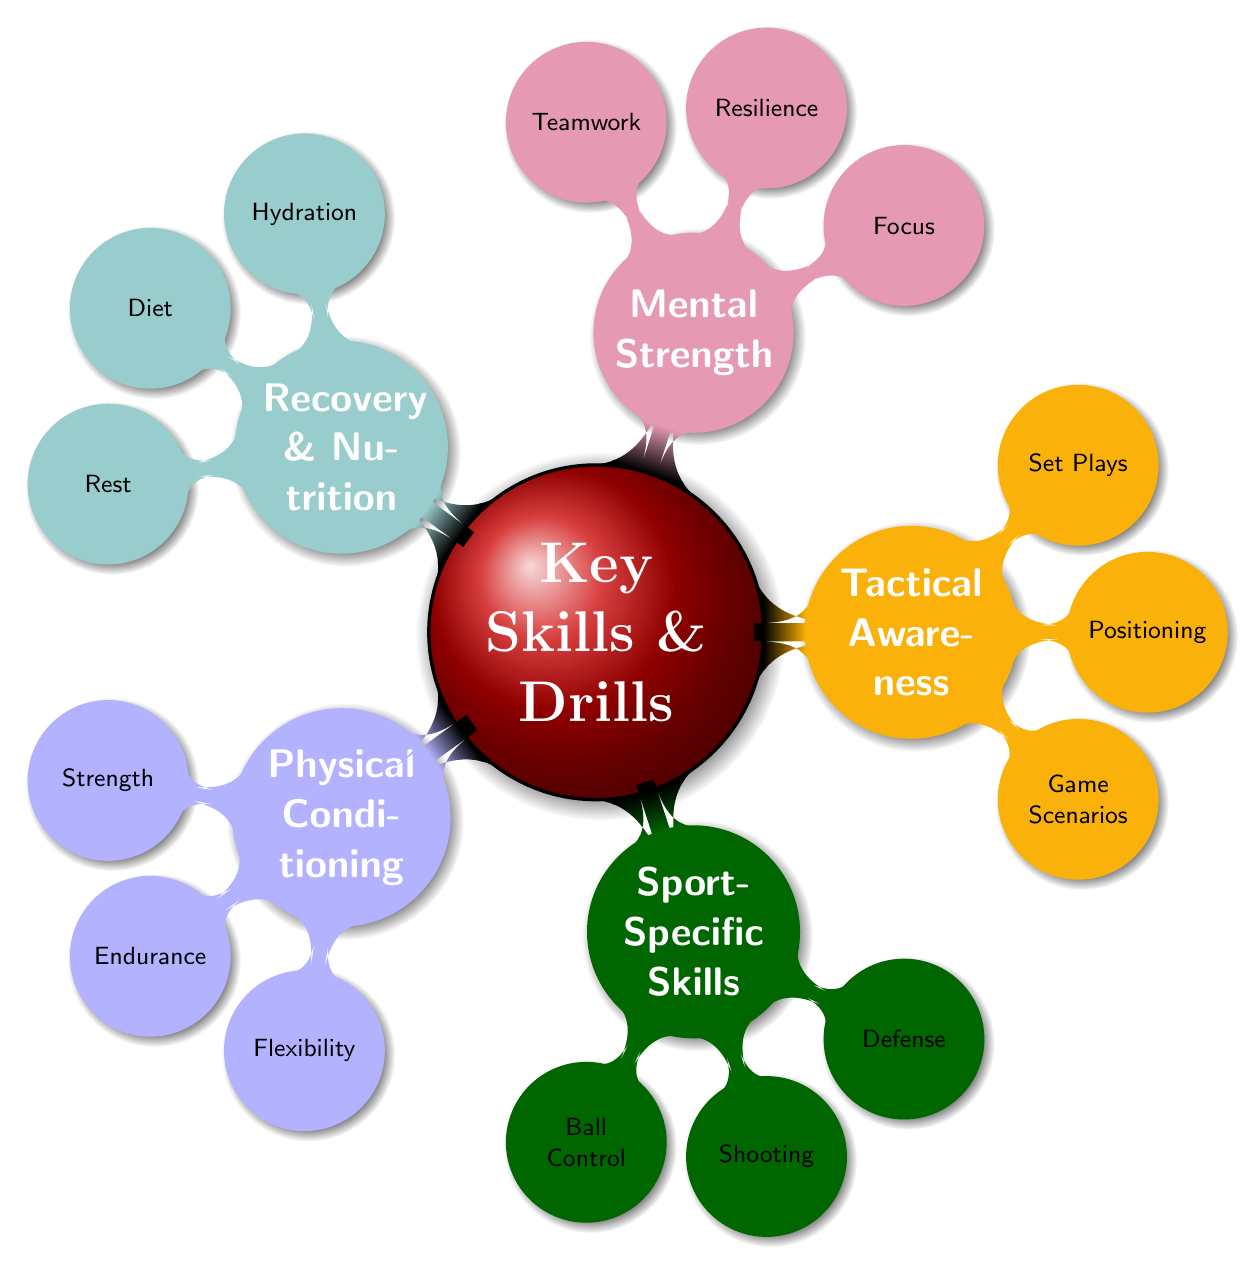What are the main categories of skills listed in the diagram? The diagram shows five main categories: Physical Conditioning, Sport-Specific Skills, Tactical Awareness, Mental Strength, and Recovery & Nutrition. Each category is a key node connecting to various skills and drills.
Answer: Physical Conditioning, Sport-Specific Skills, Tactical Awareness, Mental Strength, Recovery & Nutrition How many skills are under Sport-Specific Skills? Under the Sport-Specific Skills node, there are three sub-nodes for skills: Ball Control, Shooting, and Defensive Techniques. Therefore, the count is three.
Answer: 3 What type of drills are listed under Mental Strength? The Mental Strength category includes Focus, Resilience, and Teamwork as its sub-nodes, indicating various drills for each.
Answer: Focus, Resilience, Teamwork Which category includes yoga as a drill? Yoga is listed under the Physical Conditioning category as part of the Flexibility sub-node, reflecting its importance in enhancing flexibility for athletic performance.
Answer: Physical Conditioning Are there specific drills for recovering? Yes, under Recovery & Nutrition, there are nodes for Hydration, Diet, and Rest, indicating that there are specific drills and practices related to recovery.
Answer: Yes What type of drills are associated with Tactical Awareness? Tactical Awareness has three sub-nodes—Game Scenarios, Positioning, and Set Plays—which denote activities that enhance tactical skills through different drills and exercises.
Answer: Game Scenarios, Positioning, Set Plays What skill would you focus on to improve your endurance? Under the Physical Conditioning category, the Endurance node lists long-distance running and interval training as specific drills aimed at improving endurance.
Answer: Endurance Which skill drills are related to shooting? The Shooting sub-node under Sport-Specific Skills includes Target practice and Position-specific shooting, which are drills specifically designed to improve shooting accuracy and effectiveness.
Answer: Target practice, Position-specific shooting 